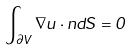Convert formula to latex. <formula><loc_0><loc_0><loc_500><loc_500>\int _ { \partial V } \nabla u \cdot n d S = 0</formula> 